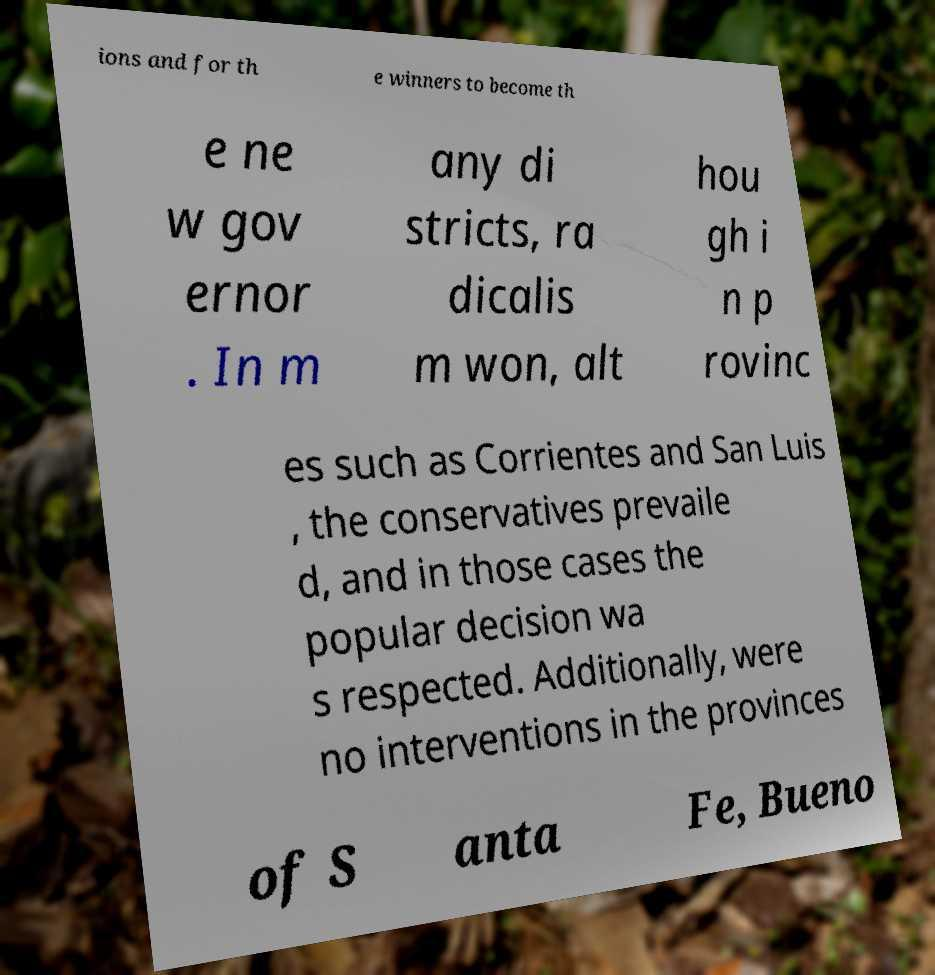Can you accurately transcribe the text from the provided image for me? ions and for th e winners to become th e ne w gov ernor . In m any di stricts, ra dicalis m won, alt hou gh i n p rovinc es such as Corrientes and San Luis , the conservatives prevaile d, and in those cases the popular decision wa s respected. Additionally, were no interventions in the provinces of S anta Fe, Bueno 